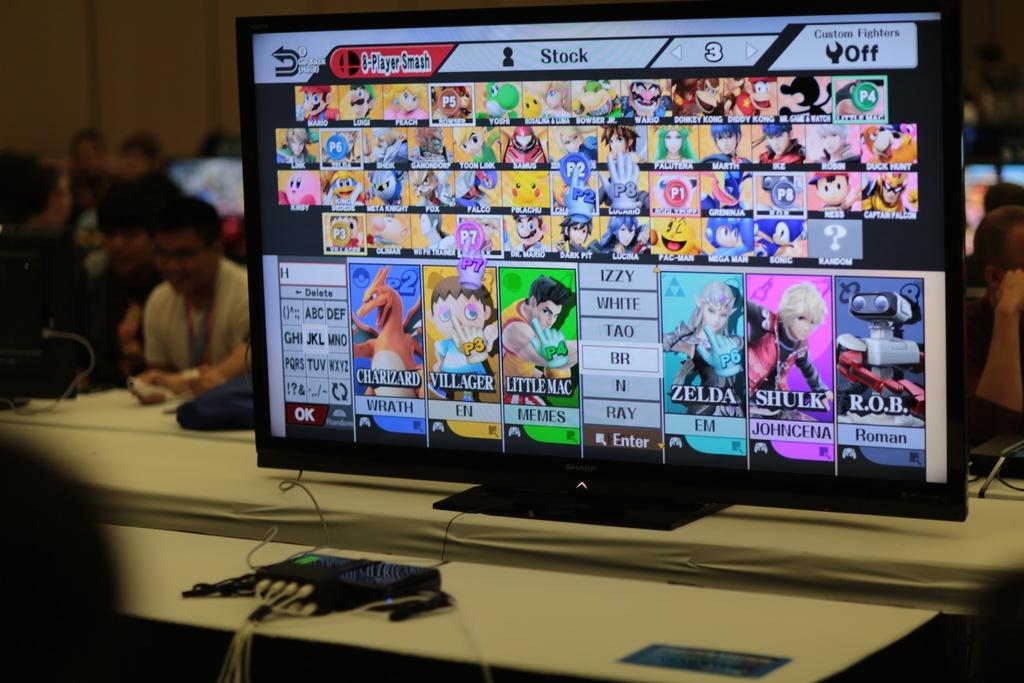What's the name of the character that looks like an orange dragon?
Provide a short and direct response. Charizard. What is the name of the princess on the screen that link always saves?
Your answer should be very brief. Zelda. 